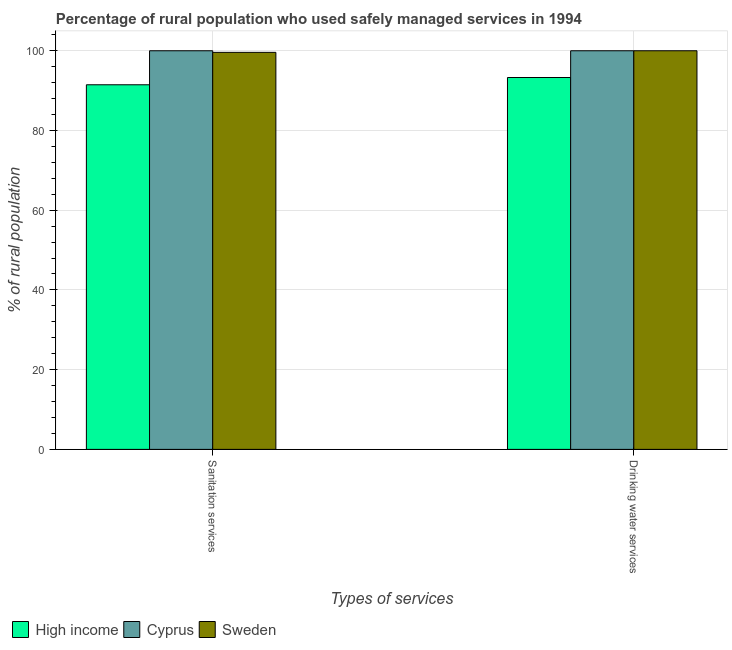How many different coloured bars are there?
Offer a very short reply. 3. How many groups of bars are there?
Your answer should be very brief. 2. Are the number of bars on each tick of the X-axis equal?
Offer a terse response. Yes. How many bars are there on the 2nd tick from the left?
Give a very brief answer. 3. What is the label of the 1st group of bars from the left?
Give a very brief answer. Sanitation services. What is the percentage of rural population who used drinking water services in High income?
Give a very brief answer. 93.29. Across all countries, what is the maximum percentage of rural population who used drinking water services?
Provide a succinct answer. 100. Across all countries, what is the minimum percentage of rural population who used sanitation services?
Keep it short and to the point. 91.47. In which country was the percentage of rural population who used sanitation services maximum?
Offer a terse response. Cyprus. What is the total percentage of rural population who used sanitation services in the graph?
Provide a short and direct response. 291.07. What is the difference between the percentage of rural population who used drinking water services in High income and that in Cyprus?
Your answer should be very brief. -6.71. What is the difference between the percentage of rural population who used sanitation services in Sweden and the percentage of rural population who used drinking water services in High income?
Your answer should be very brief. 6.31. What is the average percentage of rural population who used drinking water services per country?
Offer a terse response. 97.76. What is the difference between the percentage of rural population who used drinking water services and percentage of rural population who used sanitation services in Sweden?
Your answer should be very brief. 0.4. In how many countries, is the percentage of rural population who used sanitation services greater than 100 %?
Offer a terse response. 0. What is the ratio of the percentage of rural population who used drinking water services in Cyprus to that in High income?
Give a very brief answer. 1.07. What does the 2nd bar from the left in Drinking water services represents?
Keep it short and to the point. Cyprus. How many bars are there?
Make the answer very short. 6. Are all the bars in the graph horizontal?
Your answer should be compact. No. What is the difference between two consecutive major ticks on the Y-axis?
Keep it short and to the point. 20. Does the graph contain grids?
Ensure brevity in your answer.  Yes. Where does the legend appear in the graph?
Offer a terse response. Bottom left. How are the legend labels stacked?
Your answer should be very brief. Horizontal. What is the title of the graph?
Make the answer very short. Percentage of rural population who used safely managed services in 1994. Does "Sub-Saharan Africa (developing only)" appear as one of the legend labels in the graph?
Offer a terse response. No. What is the label or title of the X-axis?
Keep it short and to the point. Types of services. What is the label or title of the Y-axis?
Ensure brevity in your answer.  % of rural population. What is the % of rural population in High income in Sanitation services?
Offer a very short reply. 91.47. What is the % of rural population in Cyprus in Sanitation services?
Ensure brevity in your answer.  100. What is the % of rural population of Sweden in Sanitation services?
Offer a very short reply. 99.6. What is the % of rural population in High income in Drinking water services?
Your answer should be compact. 93.29. What is the % of rural population in Sweden in Drinking water services?
Your response must be concise. 100. Across all Types of services, what is the maximum % of rural population in High income?
Offer a terse response. 93.29. Across all Types of services, what is the minimum % of rural population of High income?
Offer a terse response. 91.47. Across all Types of services, what is the minimum % of rural population of Cyprus?
Keep it short and to the point. 100. Across all Types of services, what is the minimum % of rural population of Sweden?
Ensure brevity in your answer.  99.6. What is the total % of rural population of High income in the graph?
Keep it short and to the point. 184.76. What is the total % of rural population of Cyprus in the graph?
Your answer should be very brief. 200. What is the total % of rural population in Sweden in the graph?
Offer a terse response. 199.6. What is the difference between the % of rural population of High income in Sanitation services and that in Drinking water services?
Keep it short and to the point. -1.82. What is the difference between the % of rural population of Sweden in Sanitation services and that in Drinking water services?
Your answer should be compact. -0.4. What is the difference between the % of rural population in High income in Sanitation services and the % of rural population in Cyprus in Drinking water services?
Keep it short and to the point. -8.53. What is the difference between the % of rural population in High income in Sanitation services and the % of rural population in Sweden in Drinking water services?
Give a very brief answer. -8.53. What is the average % of rural population of High income per Types of services?
Your response must be concise. 92.38. What is the average % of rural population of Cyprus per Types of services?
Offer a very short reply. 100. What is the average % of rural population of Sweden per Types of services?
Offer a very short reply. 99.8. What is the difference between the % of rural population of High income and % of rural population of Cyprus in Sanitation services?
Provide a succinct answer. -8.53. What is the difference between the % of rural population of High income and % of rural population of Sweden in Sanitation services?
Your answer should be compact. -8.13. What is the difference between the % of rural population in Cyprus and % of rural population in Sweden in Sanitation services?
Your response must be concise. 0.4. What is the difference between the % of rural population of High income and % of rural population of Cyprus in Drinking water services?
Offer a terse response. -6.71. What is the difference between the % of rural population of High income and % of rural population of Sweden in Drinking water services?
Offer a very short reply. -6.71. What is the difference between the % of rural population in Cyprus and % of rural population in Sweden in Drinking water services?
Provide a short and direct response. 0. What is the ratio of the % of rural population in High income in Sanitation services to that in Drinking water services?
Ensure brevity in your answer.  0.98. What is the ratio of the % of rural population in Cyprus in Sanitation services to that in Drinking water services?
Provide a short and direct response. 1. What is the ratio of the % of rural population in Sweden in Sanitation services to that in Drinking water services?
Offer a very short reply. 1. What is the difference between the highest and the second highest % of rural population in High income?
Provide a short and direct response. 1.82. What is the difference between the highest and the lowest % of rural population of High income?
Your answer should be very brief. 1.82. What is the difference between the highest and the lowest % of rural population in Sweden?
Give a very brief answer. 0.4. 